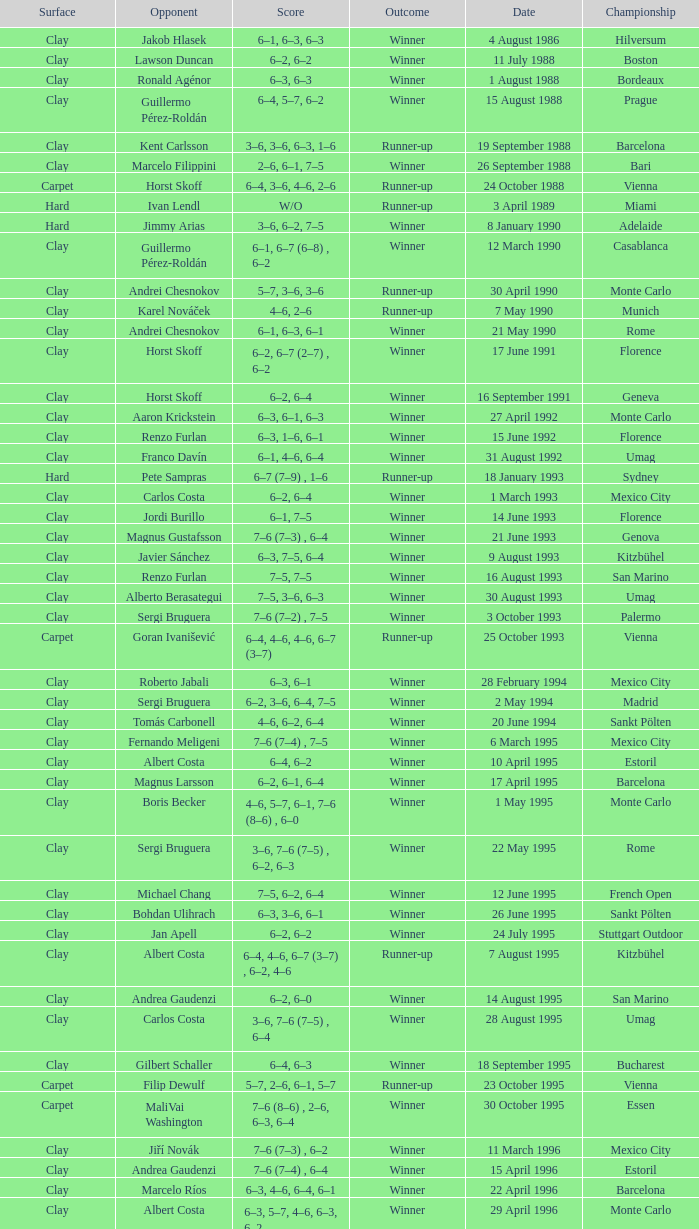What is the score when the outcome is winner against yevgeny kafelnikov? 6–2, 6–2, 6–4. 